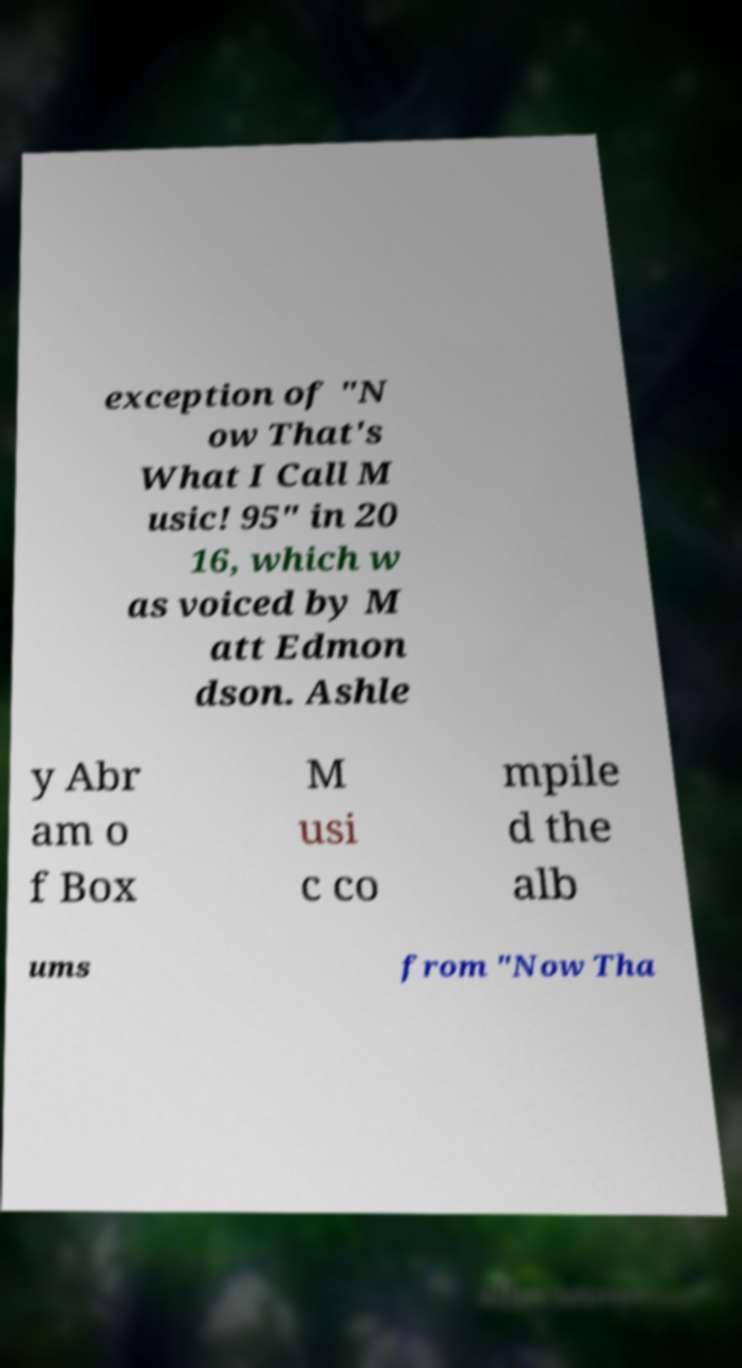Can you accurately transcribe the text from the provided image for me? exception of "N ow That's What I Call M usic! 95" in 20 16, which w as voiced by M att Edmon dson. Ashle y Abr am o f Box M usi c co mpile d the alb ums from "Now Tha 